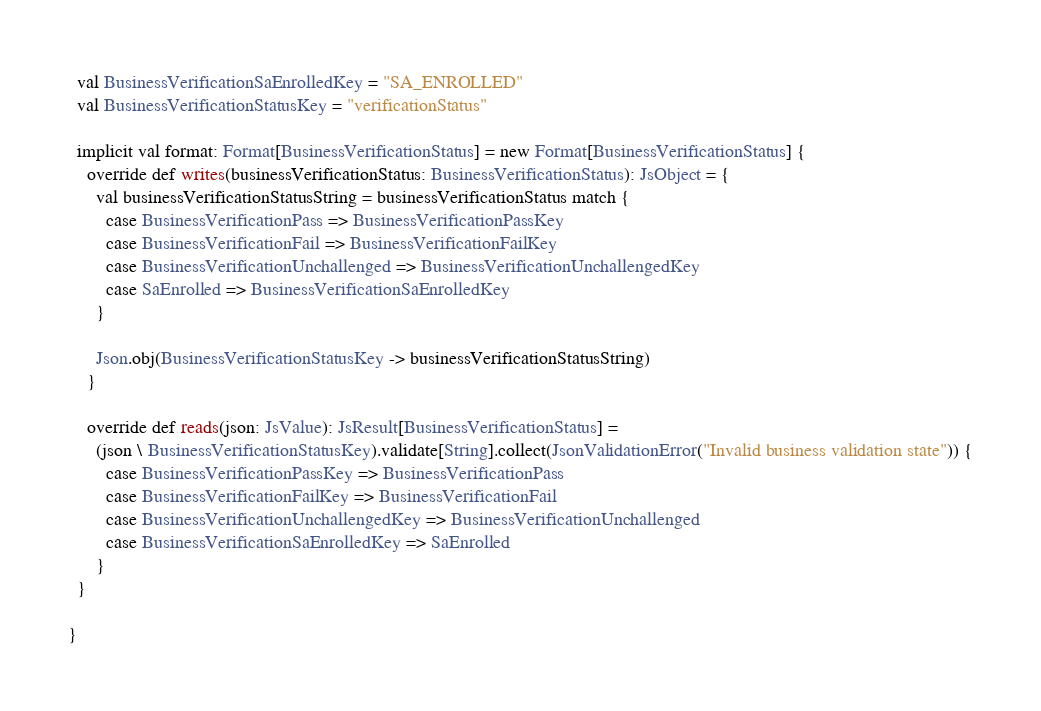Convert code to text. <code><loc_0><loc_0><loc_500><loc_500><_Scala_>  val BusinessVerificationSaEnrolledKey = "SA_ENROLLED"
  val BusinessVerificationStatusKey = "verificationStatus"

  implicit val format: Format[BusinessVerificationStatus] = new Format[BusinessVerificationStatus] {
    override def writes(businessVerificationStatus: BusinessVerificationStatus): JsObject = {
      val businessVerificationStatusString = businessVerificationStatus match {
        case BusinessVerificationPass => BusinessVerificationPassKey
        case BusinessVerificationFail => BusinessVerificationFailKey
        case BusinessVerificationUnchallenged => BusinessVerificationUnchallengedKey
        case SaEnrolled => BusinessVerificationSaEnrolledKey
      }

      Json.obj(BusinessVerificationStatusKey -> businessVerificationStatusString)
    }

    override def reads(json: JsValue): JsResult[BusinessVerificationStatus] =
      (json \ BusinessVerificationStatusKey).validate[String].collect(JsonValidationError("Invalid business validation state")) {
        case BusinessVerificationPassKey => BusinessVerificationPass
        case BusinessVerificationFailKey => BusinessVerificationFail
        case BusinessVerificationUnchallengedKey => BusinessVerificationUnchallenged
        case BusinessVerificationSaEnrolledKey => SaEnrolled
      }
  }

}</code> 